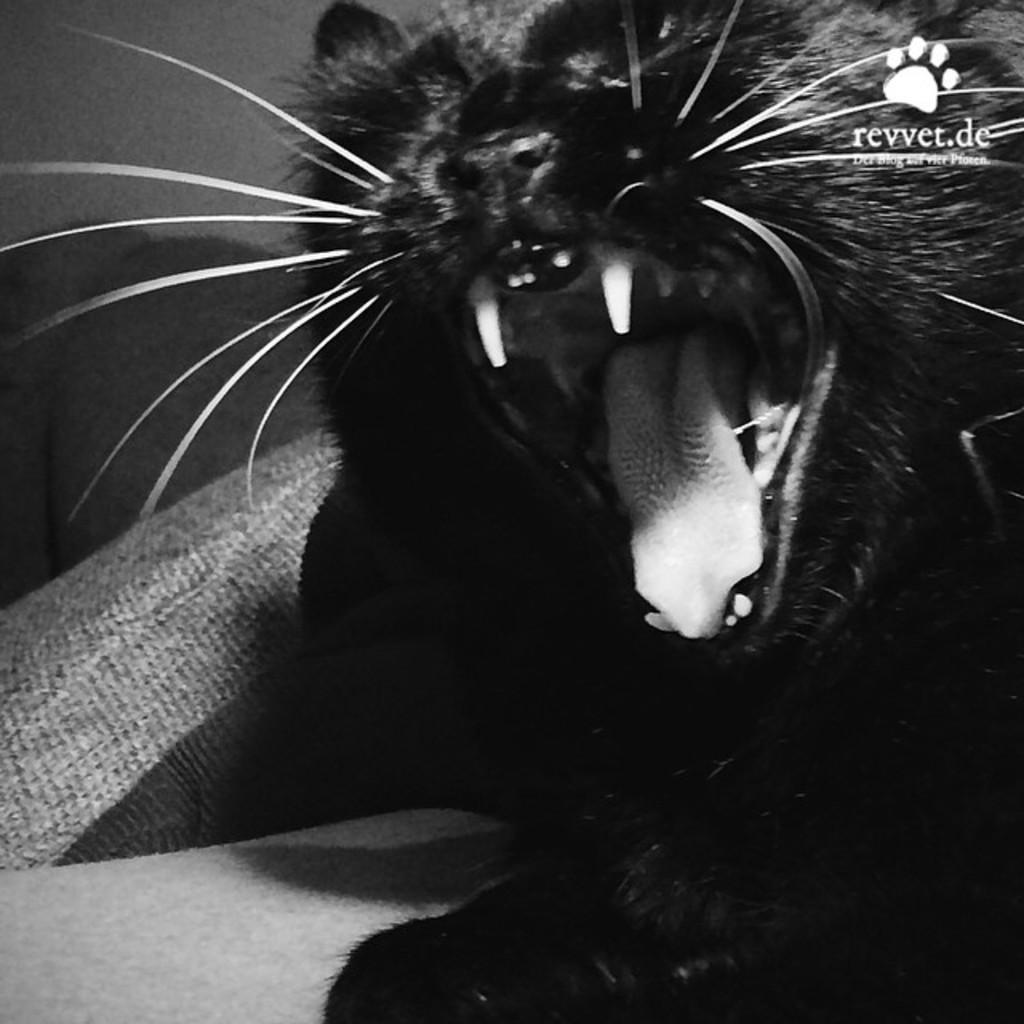Please provide a concise description of this image. In this picture there is a cat. On the left side of the image there is a cushion on the sofa. At the back there is a wall. At the top right there is text. 